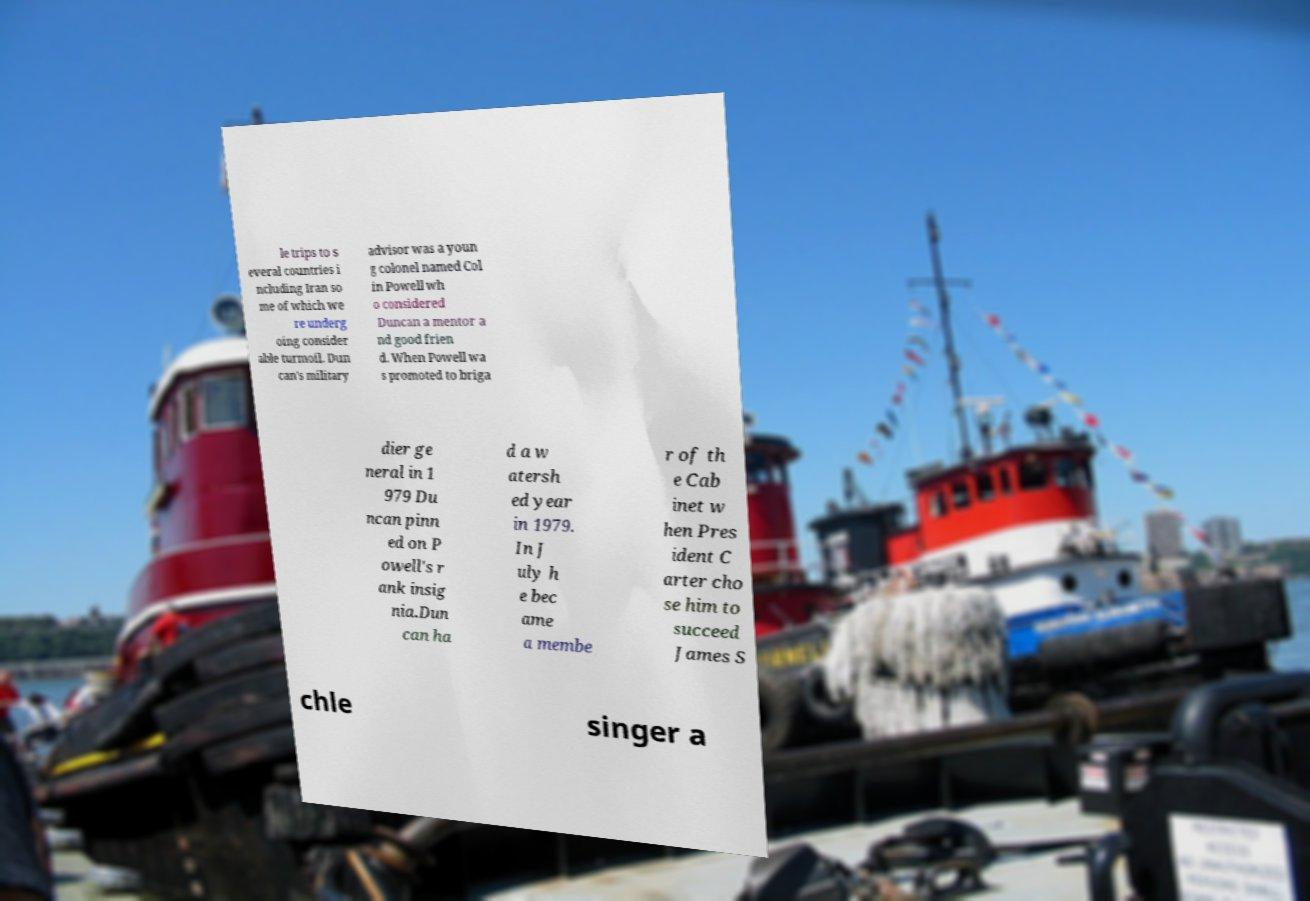For documentation purposes, I need the text within this image transcribed. Could you provide that? le trips to s everal countries i ncluding Iran so me of which we re underg oing consider able turmoil. Dun can's military advisor was a youn g colonel named Col in Powell wh o considered Duncan a mentor a nd good frien d. When Powell wa s promoted to briga dier ge neral in 1 979 Du ncan pinn ed on P owell's r ank insig nia.Dun can ha d a w atersh ed year in 1979. In J uly h e bec ame a membe r of th e Cab inet w hen Pres ident C arter cho se him to succeed James S chle singer a 